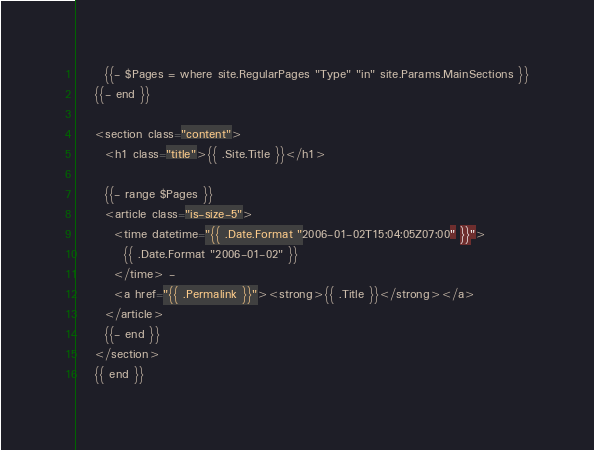<code> <loc_0><loc_0><loc_500><loc_500><_HTML_>      {{- $Pages = where site.RegularPages "Type" "in" site.Params.MainSections }}
    {{- end }}

    <section class="content">
      <h1 class="title">{{ .Site.Title }}</h1>

      {{- range $Pages }}
      <article class="is-size-5">
        <time datetime="{{ .Date.Format "2006-01-02T15:04:05Z07:00" }}">
          {{ .Date.Format "2006-01-02" }}
        </time> - 
        <a href="{{ .Permalink }}"><strong>{{ .Title }}</strong></a>
      </article>
      {{- end }}
    </section>
    {{ end }}</code> 